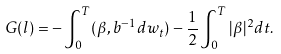<formula> <loc_0><loc_0><loc_500><loc_500>G ( l ) = - \int _ { 0 } ^ { T } ( \beta , b ^ { - 1 } d w _ { t } ) - \frac { 1 } { 2 } \int _ { 0 } ^ { T } | \beta | ^ { 2 } d t .</formula> 